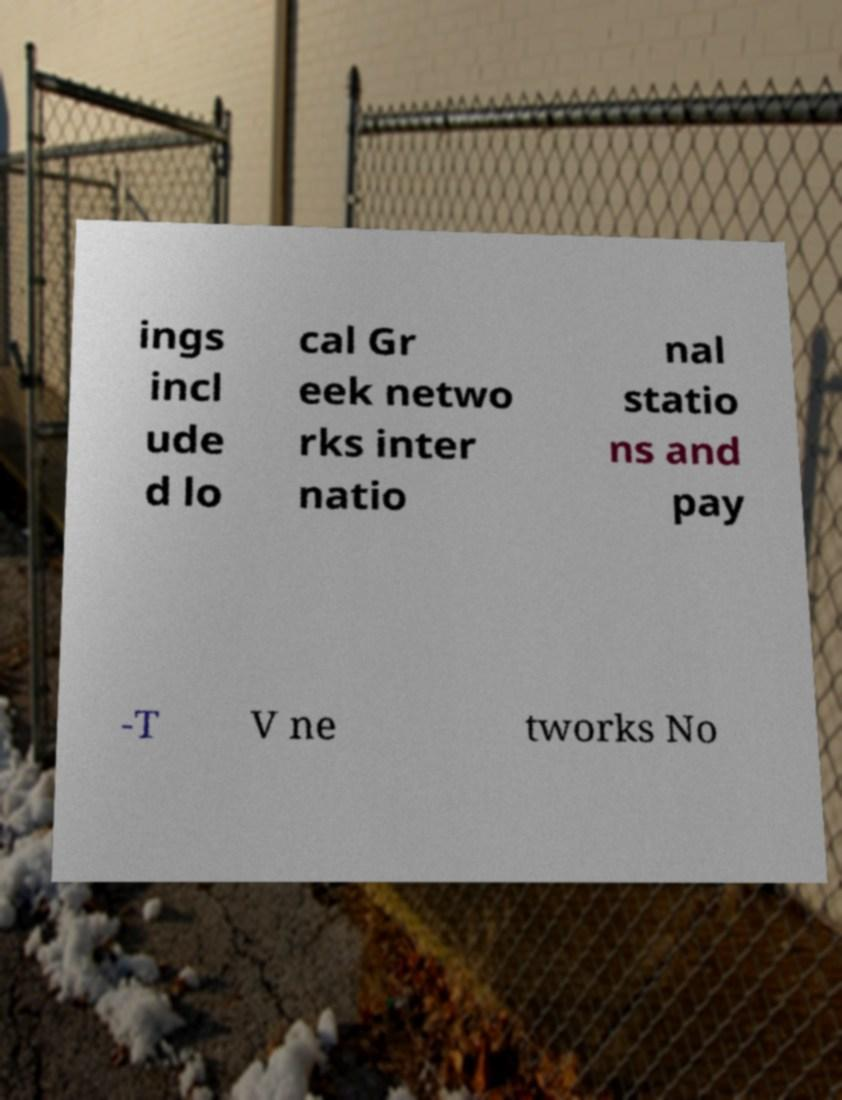Please identify and transcribe the text found in this image. ings incl ude d lo cal Gr eek netwo rks inter natio nal statio ns and pay -T V ne tworks No 